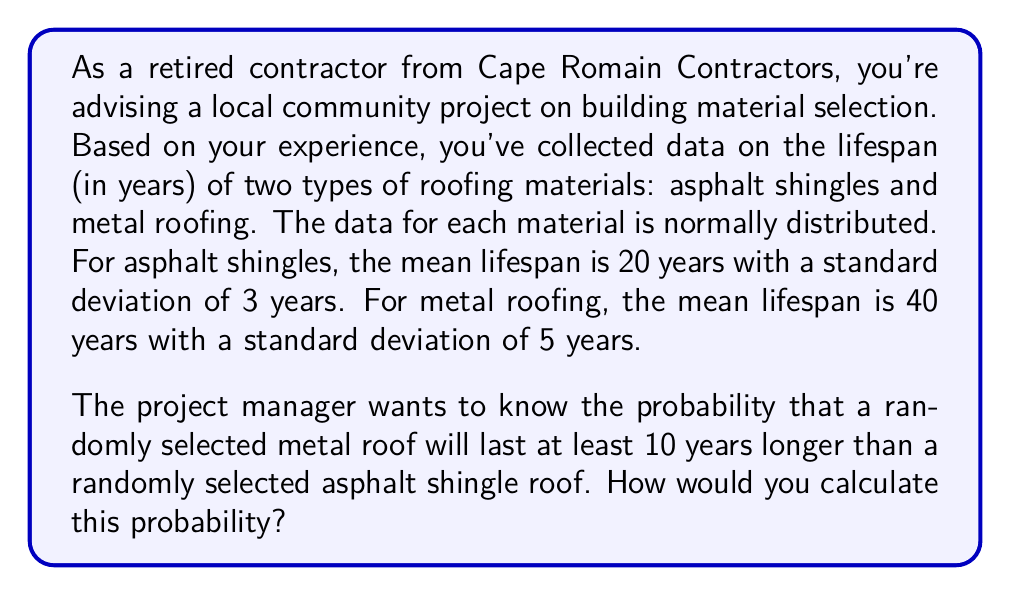Show me your answer to this math problem. To solve this problem, we need to follow these steps:

1. Define the random variables:
   Let $X$ be the lifespan of asphalt shingles and $Y$ be the lifespan of metal roofing.

2. Given information:
   $X \sim N(\mu_X = 20, \sigma_X = 3)$
   $Y \sim N(\mu_Y = 40, \sigma_Y = 5)$

3. We need to find $P(Y - X > 10)$

4. The difference of two normally distributed random variables is also normally distributed:
   $Y - X \sim N(\mu_{Y-X}, \sigma_{Y-X})$

   Where:
   $\mu_{Y-X} = \mu_Y - \mu_X = 40 - 20 = 20$
   $\sigma_{Y-X} = \sqrt{\sigma_Y^2 + \sigma_X^2} = \sqrt{5^2 + 3^2} = \sqrt{34}$

5. Now we can standardize the variable:
   $Z = \frac{(Y-X) - \mu_{Y-X}}{\sigma_{Y-X}}$

6. We want to find $P(Y - X > 10)$, which is equivalent to:
   $P(Z > \frac{10 - 20}{\sqrt{34}}) = P(Z > -\frac{10}{\sqrt{34}})$

7. Using a standard normal distribution table or calculator, we can find this probability.
Answer: The probability that a randomly selected metal roof will last at least 10 years longer than a randomly selected asphalt shingle roof is approximately 0.9571 or 95.71%.

This is calculated as:
$$P(Z > -\frac{10}{\sqrt{34}}) = P(Z > -1.715) = 1 - P(Z < -1.715) = 1 - 0.0429 = 0.9571$$ 